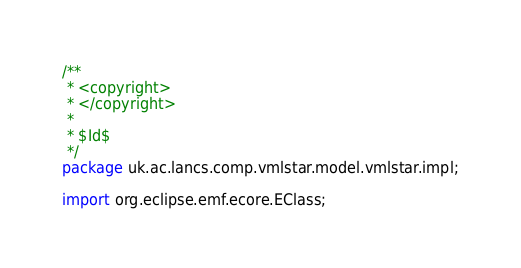<code> <loc_0><loc_0><loc_500><loc_500><_Java_>/**
 * <copyright>
 * </copyright>
 *
 * $Id$
 */
package uk.ac.lancs.comp.vmlstar.model.vmlstar.impl;

import org.eclipse.emf.ecore.EClass;</code> 